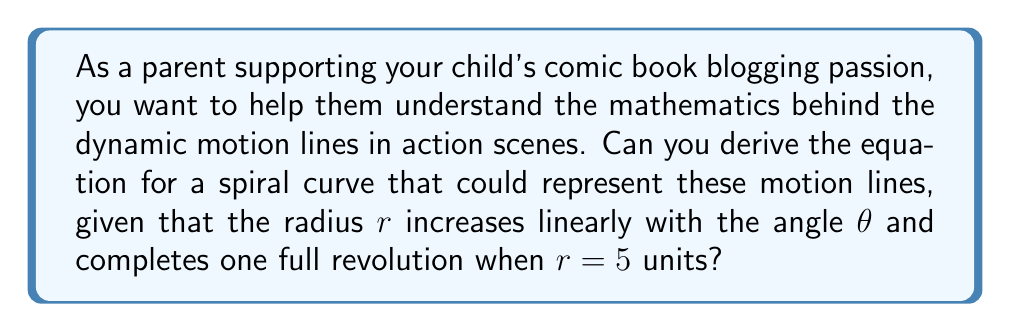What is the answer to this math problem? Let's approach this step-by-step:

1) In a spiral where the radius increases linearly with the angle, we can express the relationship as:

   $$r = a\theta + b$$

   where $a$ and $b$ are constants.

2) We know that when the spiral completes one full revolution, $\theta = 2\pi$ and $r = 5$. We can use this to set up an equation:

   $$5 = a(2\pi) + b$$

3) We also know that the spiral should start at the origin, so when $\theta = 0$, $r = 0$. This gives us another equation:

   $$0 = a(0) + b$$
   $$b = 0$$

4) Substituting $b = 0$ into the equation from step 2:

   $$5 = a(2\pi) + 0$$
   $$5 = a(2\pi)$$
   $$a = \frac{5}{2\pi}$$

5) Now we have our final equation for the spiral:

   $$r = \frac{5}{2\pi}\theta$$

6) To express this in Cartesian coordinates, we can use the standard conversion:

   $$x = r \cos(\theta) = \frac{5}{2\pi}\theta \cos(\theta)$$
   $$y = r \sin(\theta) = \frac{5}{2\pi}\theta \sin(\theta)$$

This set of parametric equations describes a spiral that could represent the motion lines in a comic book action scene, starting from the origin and making one full revolution when it reaches a radius of 5 units.
Answer: $$r = \frac{5}{2\pi}\theta$$
$$x = \frac{5}{2\pi}\theta \cos(\theta)$$
$$y = \frac{5}{2\pi}\theta \sin(\theta)$$ 